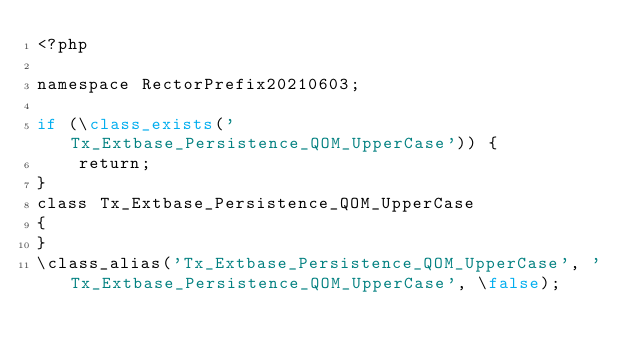Convert code to text. <code><loc_0><loc_0><loc_500><loc_500><_PHP_><?php

namespace RectorPrefix20210603;

if (\class_exists('Tx_Extbase_Persistence_QOM_UpperCase')) {
    return;
}
class Tx_Extbase_Persistence_QOM_UpperCase
{
}
\class_alias('Tx_Extbase_Persistence_QOM_UpperCase', 'Tx_Extbase_Persistence_QOM_UpperCase', \false);
</code> 